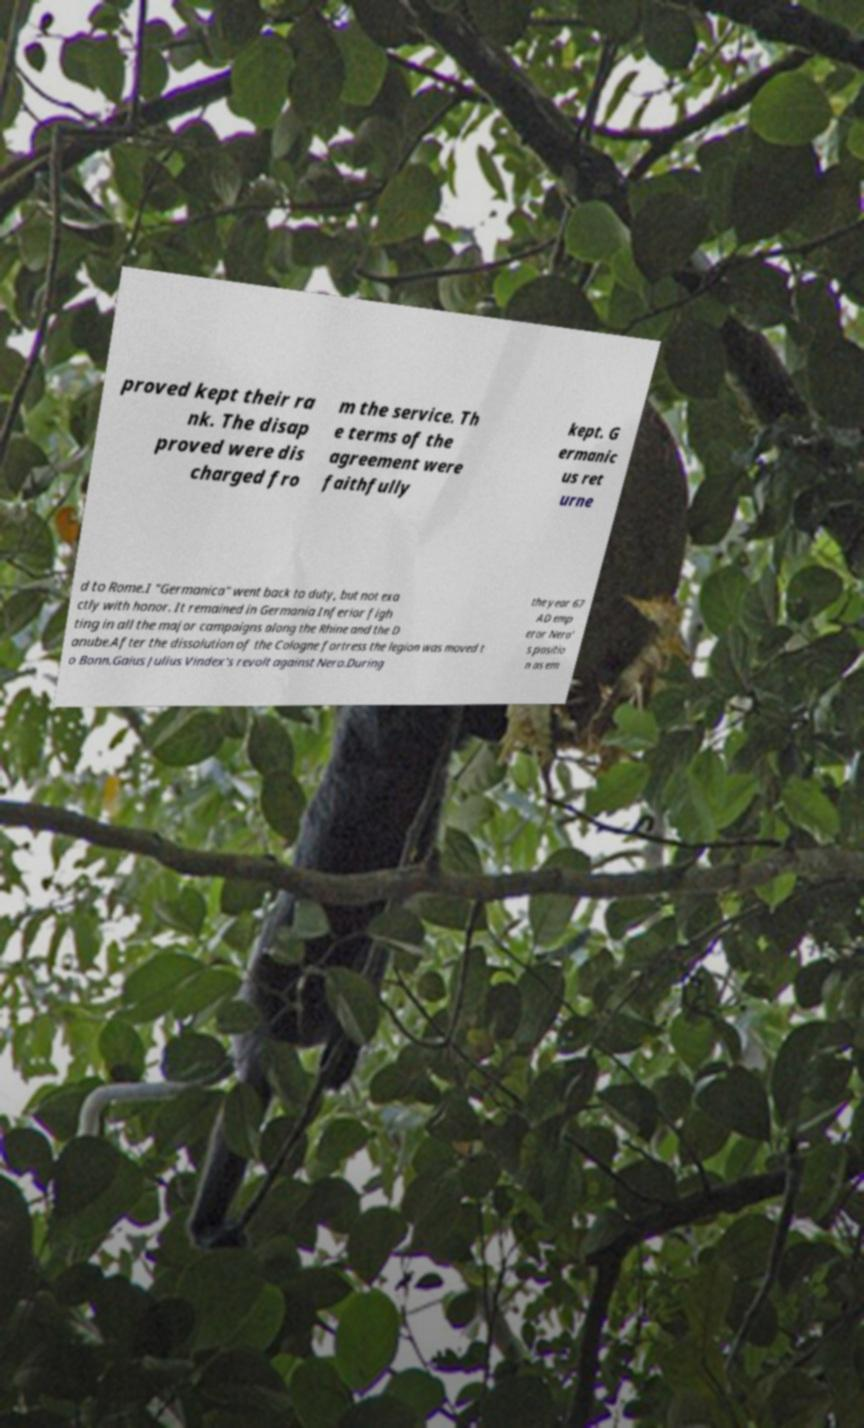Please read and relay the text visible in this image. What does it say? proved kept their ra nk. The disap proved were dis charged fro m the service. Th e terms of the agreement were faithfully kept. G ermanic us ret urne d to Rome.I "Germanica" went back to duty, but not exa ctly with honor. It remained in Germania Inferior figh ting in all the major campaigns along the Rhine and the D anube.After the dissolution of the Cologne fortress the legion was moved t o Bonn.Gaius Julius Vindex's revolt against Nero.During the year 67 AD emp eror Nero' s positio n as em 